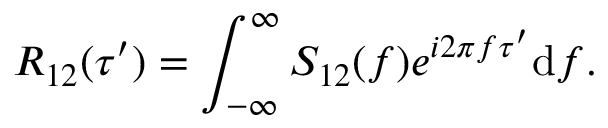Convert formula to latex. <formula><loc_0><loc_0><loc_500><loc_500>R _ { 1 2 } ( \tau ^ { \prime } ) = \int _ { - \infty } ^ { \infty } S _ { 1 2 } ( f ) e ^ { i 2 \pi f \tau ^ { \prime } } d f .</formula> 